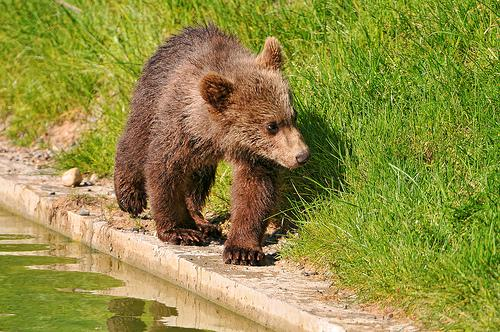Question: what kind of animal is this?
Choices:
A. Lion.
B. Tiger.
C. Bear.
D. Rabbit.
Answer with the letter. Answer: C Question: what is on the animal's left?
Choices:
A. Grass.
B. Fence.
C. Another animal.
D. Kids.
Answer with the letter. Answer: A Question: who is walking on the cement ledge?
Choices:
A. Elephant.
B. Tim Tebow.
C. Will Smith.
D. The bear.
Answer with the letter. Answer: D Question: what direction is the bear looking?
Choices:
A. His right.
B. Straight forward.
C. Down.
D. To his left.
Answer with the letter. Answer: D Question: what color is the bear?
Choices:
A. Black.
B. White.
C. Brown.
D. Grey.
Answer with the letter. Answer: C Question: what is on the bear's right?
Choices:
A. Water.
B. Grass.
C. Fence.
D. Mountains.
Answer with the letter. Answer: A Question: how many of the bear's eyes can you see?
Choices:
A. Two.
B. One.
C. None.
D. Zero.
Answer with the letter. Answer: B 